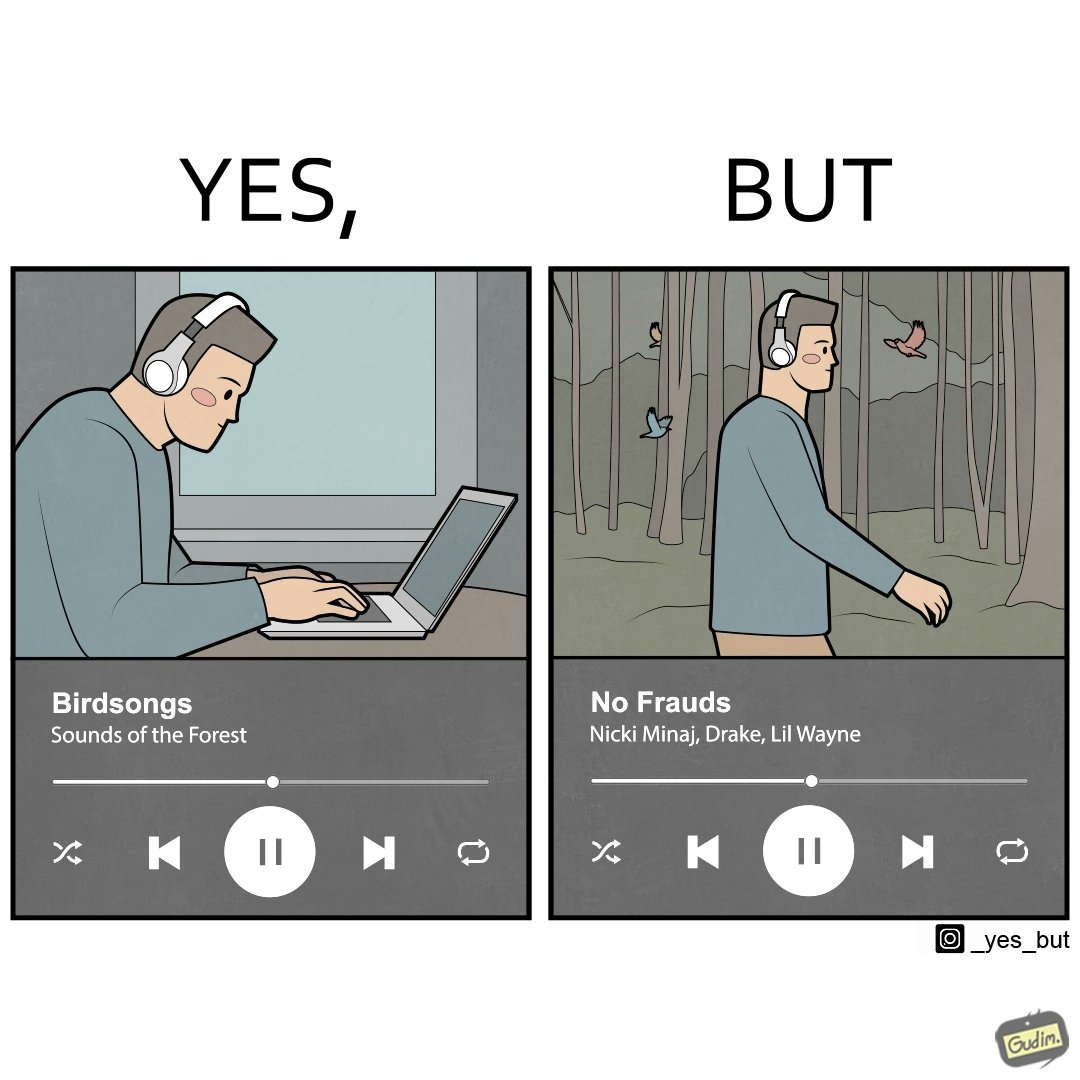What do you see in each half of this image? In the left part of the image: a person working on laptop while hearing to some songs on his headphone, at the bottom of the image the music player is seen with some name as "Birdsongs" In the right part of the image: a person walking through some forest while hearing to some songs on his headphone, at the bottom of the image the music player is seen with some name as "No Frauds" 